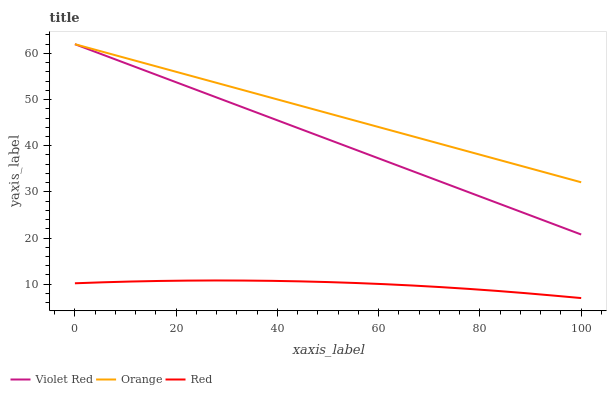Does Red have the minimum area under the curve?
Answer yes or no. Yes. Does Orange have the maximum area under the curve?
Answer yes or no. Yes. Does Violet Red have the minimum area under the curve?
Answer yes or no. No. Does Violet Red have the maximum area under the curve?
Answer yes or no. No. Is Violet Red the smoothest?
Answer yes or no. Yes. Is Red the roughest?
Answer yes or no. Yes. Is Red the smoothest?
Answer yes or no. No. Is Violet Red the roughest?
Answer yes or no. No. Does Red have the lowest value?
Answer yes or no. Yes. Does Violet Red have the lowest value?
Answer yes or no. No. Does Violet Red have the highest value?
Answer yes or no. Yes. Does Red have the highest value?
Answer yes or no. No. Is Red less than Violet Red?
Answer yes or no. Yes. Is Orange greater than Red?
Answer yes or no. Yes. Does Orange intersect Violet Red?
Answer yes or no. Yes. Is Orange less than Violet Red?
Answer yes or no. No. Is Orange greater than Violet Red?
Answer yes or no. No. Does Red intersect Violet Red?
Answer yes or no. No. 